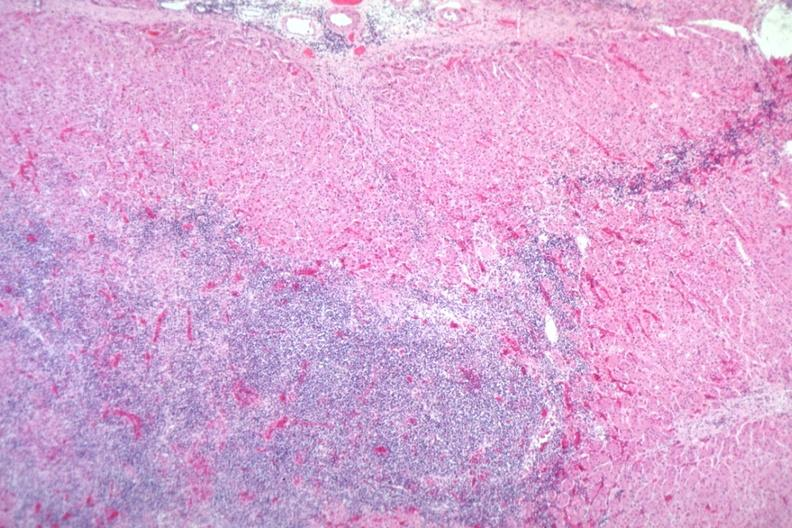s lymphoma present?
Answer the question using a single word or phrase. Yes 